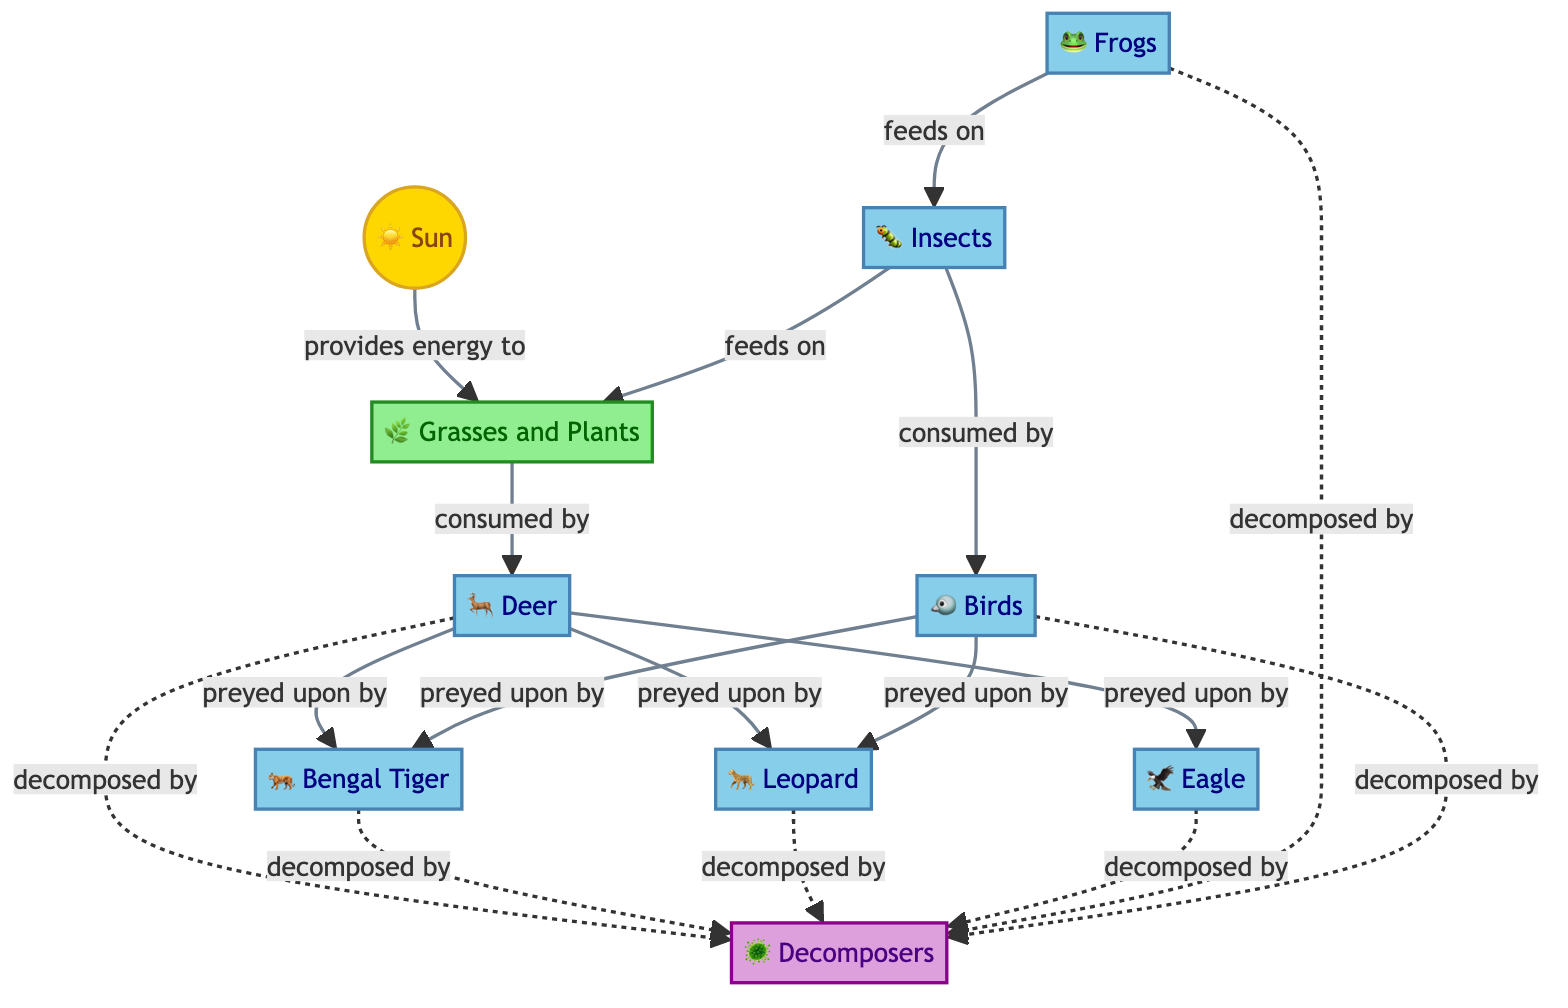What is the primary energy source in the food chain? The diagram identifies the sun as the initial energy source in the food chain, represented by the node containing the sun symbol. Thus, the primary energy source is the sun.
Answer: Sun How many types of consumers are present in this food chain? The diagram includes five different consumer types: deer, Bengal tiger, leopard, eagle, frogs, insects, and birds. Counting these distinct nodes results in seven consumer types.
Answer: Seven Which organism is a predator to the deer? According to the diagram, both the Bengal tiger and the leopard prey on the deer, confirming that they are predators to the deer.
Answer: Bengal tiger, leopard What do insects feed on? The diagram indicates that insects feed on grasses and plants, as shown by the direct connection from the insect node to the plant node, indicating a feeding relationship.
Answer: Grasses and plants How do birds relate to the food chain? The diagram shows that birds are consumers that prey on insects, establishing their position in the food chain where they feed on the insects.
Answer: Prey on insects Which organism is at the top of the food chain? The diagram indicates that the Bengal tiger is positioned at the top as it preys on deer, confirming its apex predator status within this specific food chain.
Answer: Bengal tiger What is the role of decomposers in the ecosystem? The diagram shows that decomposers are linked to various organisms, indicating they are responsible for breaking down dead organic matter from those organisms, thus recycling nutrients back into the ecosystem.
Answer: Break down dead organic matter How many producers are in the food chain? The diagram shows only one producer type, which is grasses and plants, identified as the source of energy for the consumers in the chain.
Answer: One Which consumer preys on birds? Referring to the diagram, both the Bengal tiger and the leopard are depicted as predators of birds, indicating they hunt and consume this organism.
Answer: Bengal tiger, leopard 